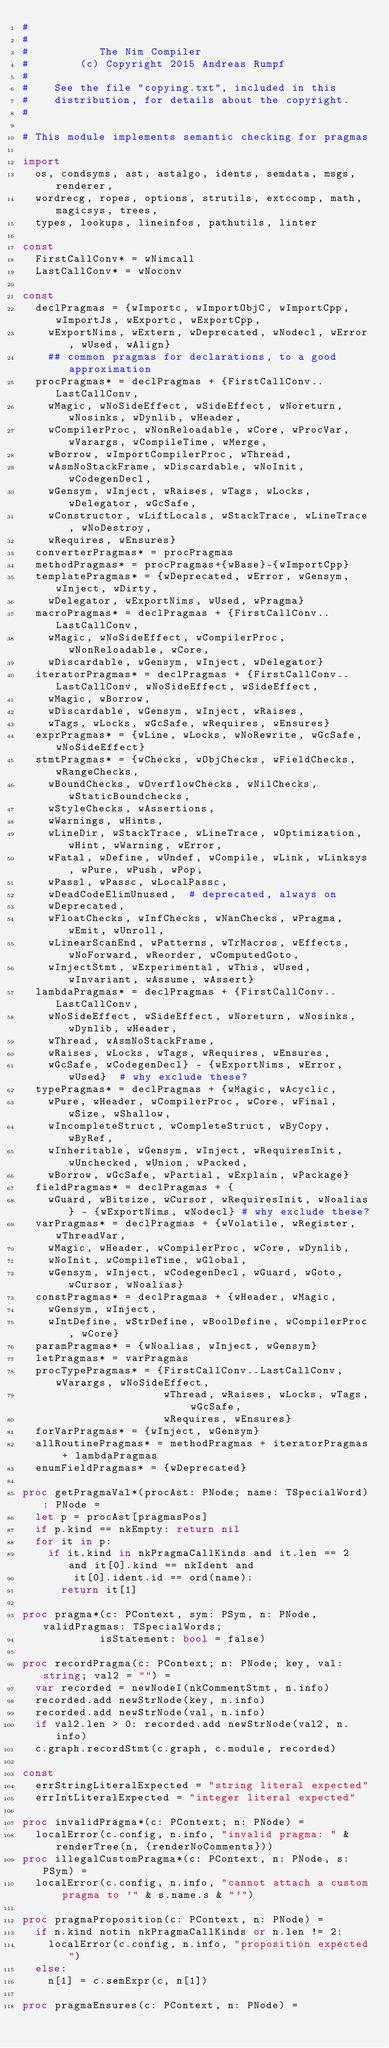Convert code to text. <code><loc_0><loc_0><loc_500><loc_500><_Nim_>#
#
#           The Nim Compiler
#        (c) Copyright 2015 Andreas Rumpf
#
#    See the file "copying.txt", included in this
#    distribution, for details about the copyright.
#

# This module implements semantic checking for pragmas

import
  os, condsyms, ast, astalgo, idents, semdata, msgs, renderer,
  wordrecg, ropes, options, strutils, extccomp, math, magicsys, trees,
  types, lookups, lineinfos, pathutils, linter

const
  FirstCallConv* = wNimcall
  LastCallConv* = wNoconv

const
  declPragmas = {wImportc, wImportObjC, wImportCpp, wImportJs, wExportc, wExportCpp,
    wExportNims, wExtern, wDeprecated, wNodecl, wError, wUsed, wAlign}
    ## common pragmas for declarations, to a good approximation
  procPragmas* = declPragmas + {FirstCallConv..LastCallConv,
    wMagic, wNoSideEffect, wSideEffect, wNoreturn, wNosinks, wDynlib, wHeader,
    wCompilerProc, wNonReloadable, wCore, wProcVar, wVarargs, wCompileTime, wMerge,
    wBorrow, wImportCompilerProc, wThread,
    wAsmNoStackFrame, wDiscardable, wNoInit, wCodegenDecl,
    wGensym, wInject, wRaises, wTags, wLocks, wDelegator, wGcSafe,
    wConstructor, wLiftLocals, wStackTrace, wLineTrace, wNoDestroy,
    wRequires, wEnsures}
  converterPragmas* = procPragmas
  methodPragmas* = procPragmas+{wBase}-{wImportCpp}
  templatePragmas* = {wDeprecated, wError, wGensym, wInject, wDirty,
    wDelegator, wExportNims, wUsed, wPragma}
  macroPragmas* = declPragmas + {FirstCallConv..LastCallConv,
    wMagic, wNoSideEffect, wCompilerProc, wNonReloadable, wCore,
    wDiscardable, wGensym, wInject, wDelegator}
  iteratorPragmas* = declPragmas + {FirstCallConv..LastCallConv, wNoSideEffect, wSideEffect,
    wMagic, wBorrow,
    wDiscardable, wGensym, wInject, wRaises,
    wTags, wLocks, wGcSafe, wRequires, wEnsures}
  exprPragmas* = {wLine, wLocks, wNoRewrite, wGcSafe, wNoSideEffect}
  stmtPragmas* = {wChecks, wObjChecks, wFieldChecks, wRangeChecks,
    wBoundChecks, wOverflowChecks, wNilChecks, wStaticBoundchecks,
    wStyleChecks, wAssertions,
    wWarnings, wHints,
    wLineDir, wStackTrace, wLineTrace, wOptimization, wHint, wWarning, wError,
    wFatal, wDefine, wUndef, wCompile, wLink, wLinksys, wPure, wPush, wPop,
    wPassl, wPassc, wLocalPassc,
    wDeadCodeElimUnused,  # deprecated, always on
    wDeprecated,
    wFloatChecks, wInfChecks, wNanChecks, wPragma, wEmit, wUnroll,
    wLinearScanEnd, wPatterns, wTrMacros, wEffects, wNoForward, wReorder, wComputedGoto,
    wInjectStmt, wExperimental, wThis, wUsed, wInvariant, wAssume, wAssert}
  lambdaPragmas* = declPragmas + {FirstCallConv..LastCallConv,
    wNoSideEffect, wSideEffect, wNoreturn, wNosinks, wDynlib, wHeader,
    wThread, wAsmNoStackFrame,
    wRaises, wLocks, wTags, wRequires, wEnsures,
    wGcSafe, wCodegenDecl} - {wExportNims, wError, wUsed}  # why exclude these?
  typePragmas* = declPragmas + {wMagic, wAcyclic,
    wPure, wHeader, wCompilerProc, wCore, wFinal, wSize, wShallow,
    wIncompleteStruct, wCompleteStruct, wByCopy, wByRef,
    wInheritable, wGensym, wInject, wRequiresInit, wUnchecked, wUnion, wPacked,
    wBorrow, wGcSafe, wPartial, wExplain, wPackage}
  fieldPragmas* = declPragmas + {
    wGuard, wBitsize, wCursor, wRequiresInit, wNoalias} - {wExportNims, wNodecl} # why exclude these?
  varPragmas* = declPragmas + {wVolatile, wRegister, wThreadVar,
    wMagic, wHeader, wCompilerProc, wCore, wDynlib,
    wNoInit, wCompileTime, wGlobal,
    wGensym, wInject, wCodegenDecl, wGuard, wGoto, wCursor, wNoalias}
  constPragmas* = declPragmas + {wHeader, wMagic,
    wGensym, wInject,
    wIntDefine, wStrDefine, wBoolDefine, wCompilerProc, wCore}
  paramPragmas* = {wNoalias, wInject, wGensym}
  letPragmas* = varPragmas
  procTypePragmas* = {FirstCallConv..LastCallConv, wVarargs, wNoSideEffect,
                      wThread, wRaises, wLocks, wTags, wGcSafe,
                      wRequires, wEnsures}
  forVarPragmas* = {wInject, wGensym}
  allRoutinePragmas* = methodPragmas + iteratorPragmas + lambdaPragmas
  enumFieldPragmas* = {wDeprecated}

proc getPragmaVal*(procAst: PNode; name: TSpecialWord): PNode =
  let p = procAst[pragmasPos]
  if p.kind == nkEmpty: return nil
  for it in p:
    if it.kind in nkPragmaCallKinds and it.len == 2 and it[0].kind == nkIdent and
        it[0].ident.id == ord(name):
      return it[1]

proc pragma*(c: PContext, sym: PSym, n: PNode, validPragmas: TSpecialWords;
            isStatement: bool = false)

proc recordPragma(c: PContext; n: PNode; key, val: string; val2 = "") =
  var recorded = newNodeI(nkCommentStmt, n.info)
  recorded.add newStrNode(key, n.info)
  recorded.add newStrNode(val, n.info)
  if val2.len > 0: recorded.add newStrNode(val2, n.info)
  c.graph.recordStmt(c.graph, c.module, recorded)

const
  errStringLiteralExpected = "string literal expected"
  errIntLiteralExpected = "integer literal expected"

proc invalidPragma*(c: PContext; n: PNode) =
  localError(c.config, n.info, "invalid pragma: " & renderTree(n, {renderNoComments}))
proc illegalCustomPragma*(c: PContext, n: PNode, s: PSym) =
  localError(c.config, n.info, "cannot attach a custom pragma to '" & s.name.s & "'")

proc pragmaProposition(c: PContext, n: PNode) =
  if n.kind notin nkPragmaCallKinds or n.len != 2:
    localError(c.config, n.info, "proposition expected")
  else:
    n[1] = c.semExpr(c, n[1])

proc pragmaEnsures(c: PContext, n: PNode) =</code> 